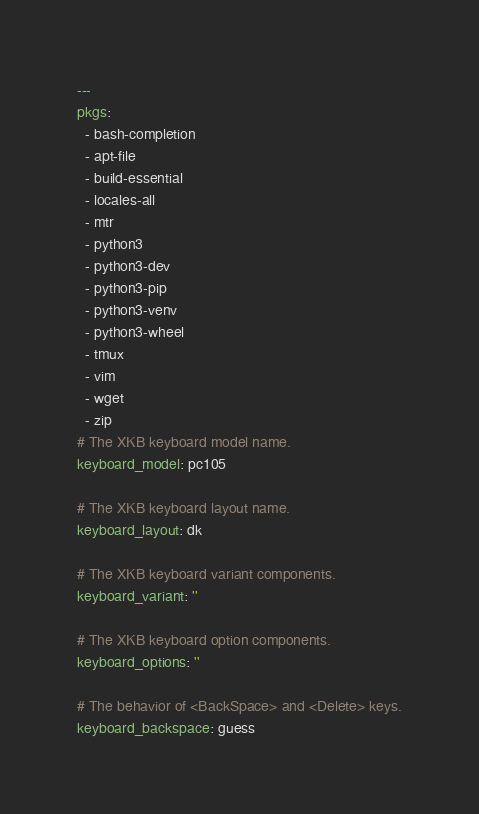<code> <loc_0><loc_0><loc_500><loc_500><_YAML_>---
pkgs:
  - bash-completion
  - apt-file
  - build-essential
  - locales-all
  - mtr
  - python3
  - python3-dev
  - python3-pip
  - python3-venv
  - python3-wheel
  - tmux
  - vim
  - wget
  - zip
# The XKB keyboard model name.
keyboard_model: pc105

# The XKB keyboard layout name.
keyboard_layout: dk

# The XKB keyboard variant components.
keyboard_variant: ''

# The XKB keyboard option components.
keyboard_options: ''

# The behavior of <BackSpace> and <Delete> keys.
keyboard_backspace: guess
</code> 